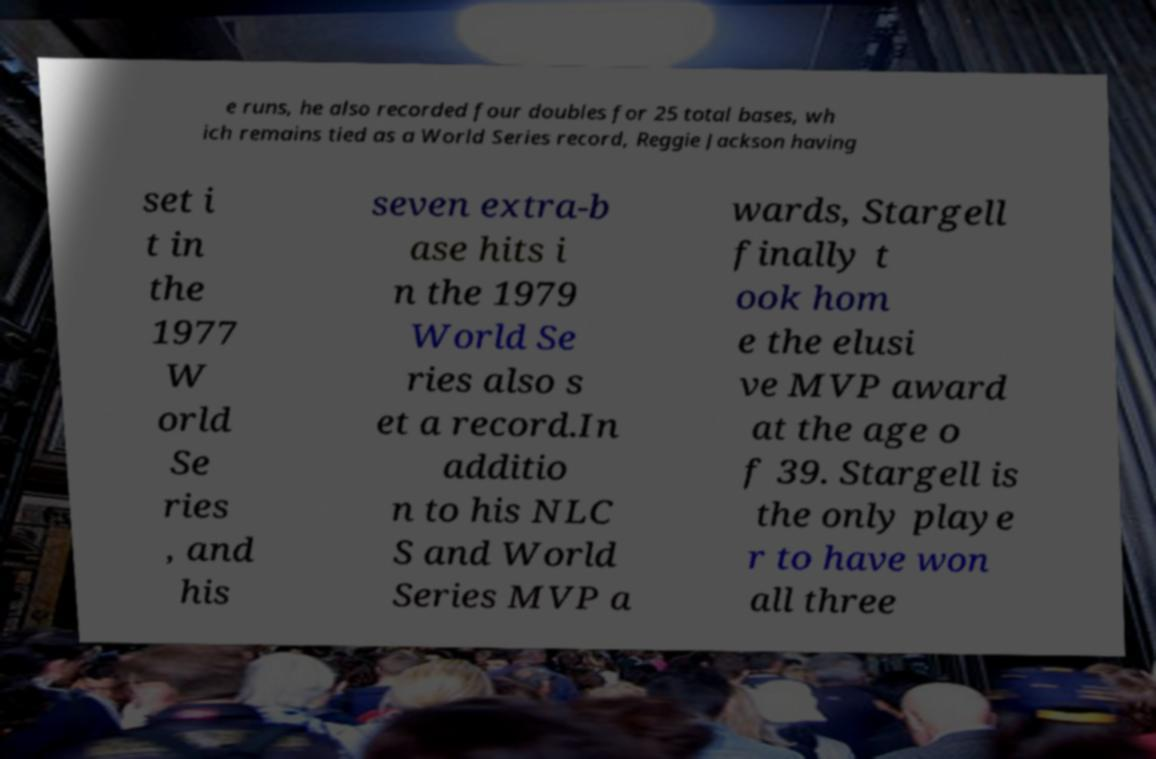For documentation purposes, I need the text within this image transcribed. Could you provide that? e runs, he also recorded four doubles for 25 total bases, wh ich remains tied as a World Series record, Reggie Jackson having set i t in the 1977 W orld Se ries , and his seven extra-b ase hits i n the 1979 World Se ries also s et a record.In additio n to his NLC S and World Series MVP a wards, Stargell finally t ook hom e the elusi ve MVP award at the age o f 39. Stargell is the only playe r to have won all three 